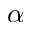<formula> <loc_0><loc_0><loc_500><loc_500>\alpha</formula> 